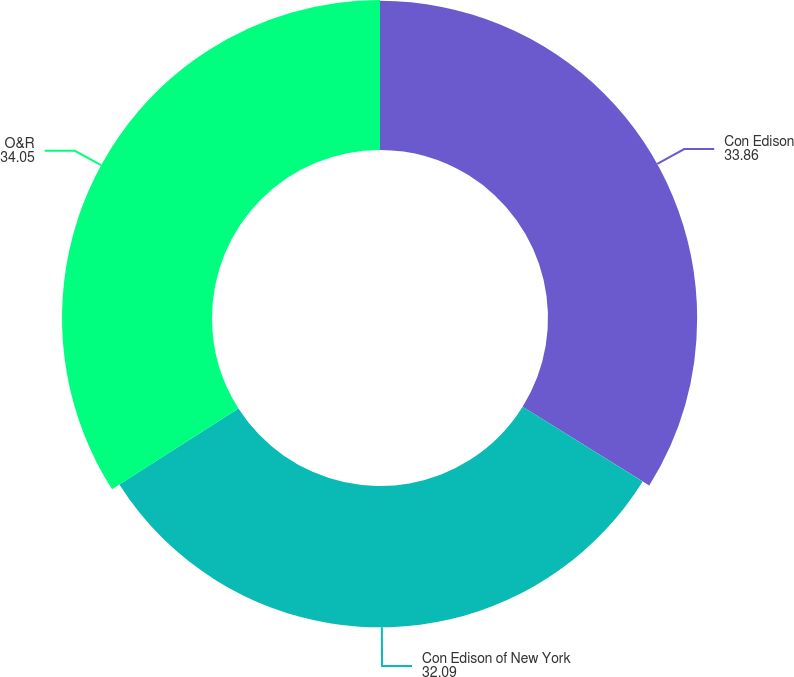Convert chart. <chart><loc_0><loc_0><loc_500><loc_500><pie_chart><fcel>Con Edison<fcel>Con Edison of New York<fcel>O&R<nl><fcel>33.86%<fcel>32.09%<fcel>34.05%<nl></chart> 